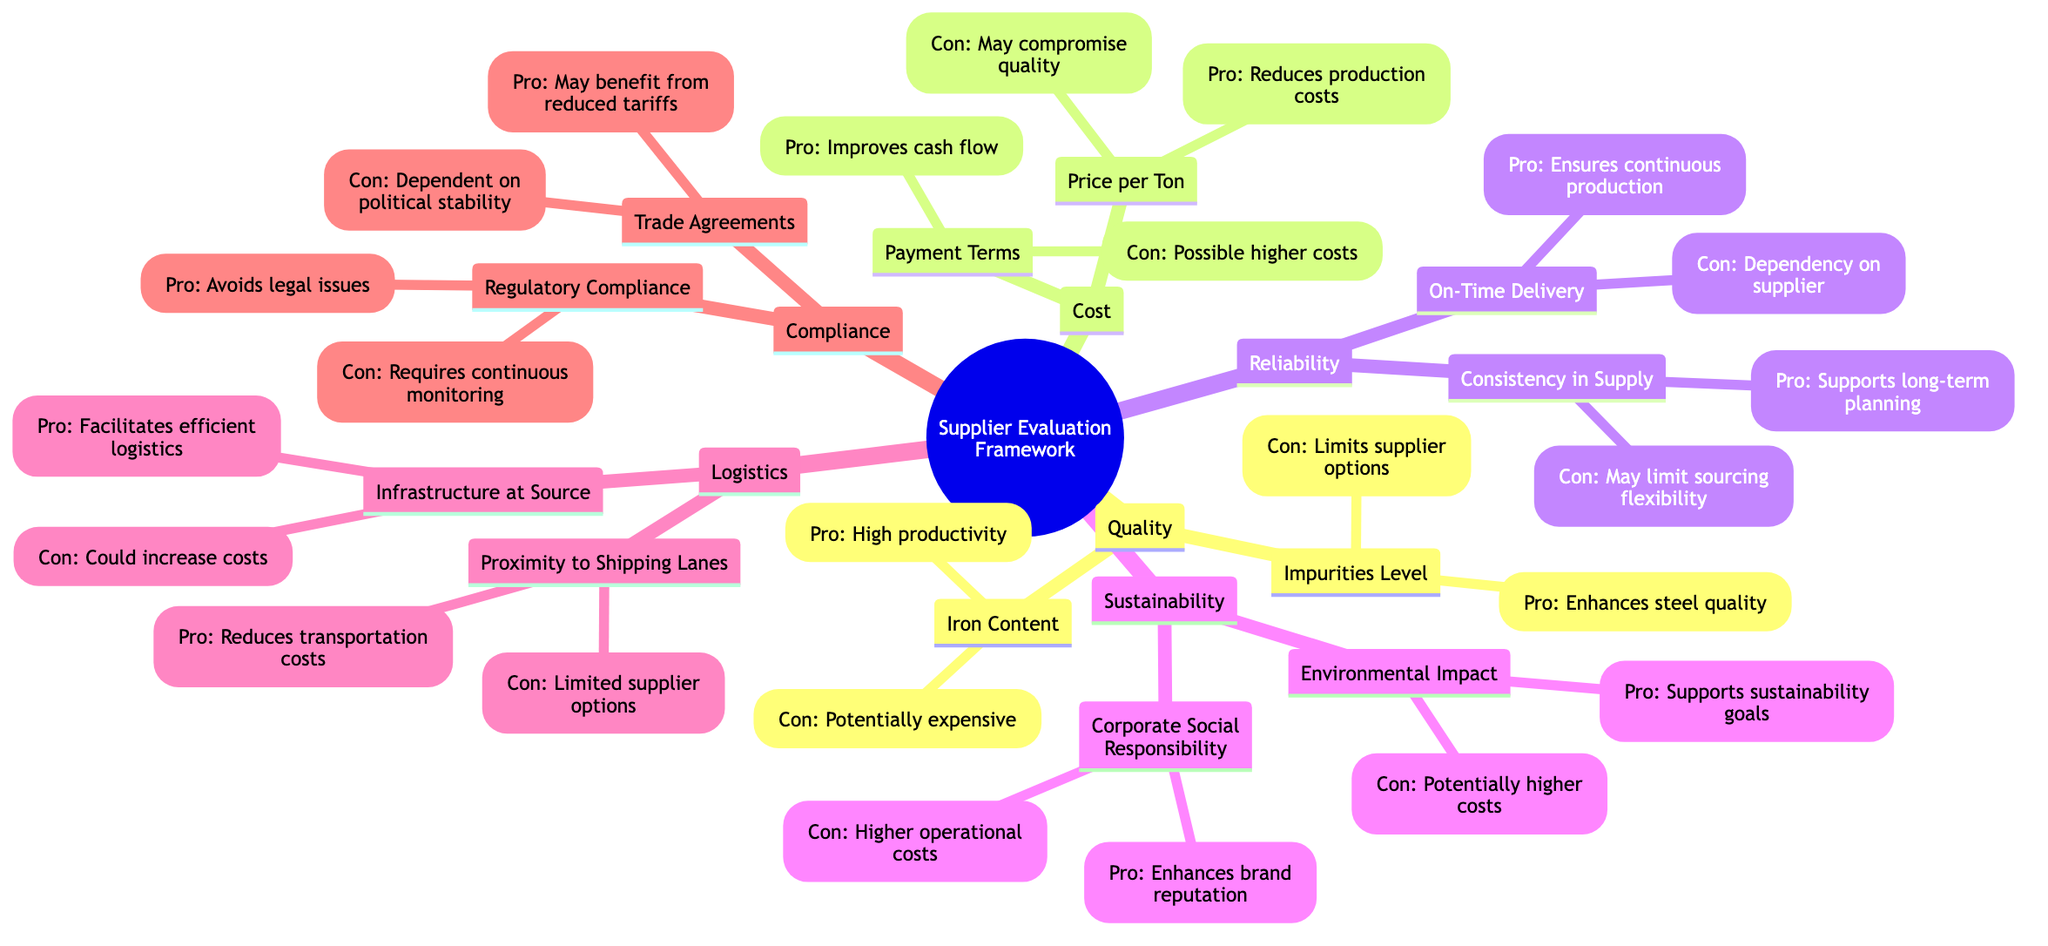What is one pro of high iron content? The pro listed for high iron content is that it increases productivity and reduces waste in steel production.
Answer: High productivity What do lower impurities enhance? According to the diagram, lower impurities enhance steel quality, which is specified as a pro under the Impurities Level category.
Answer: Steel quality How many categories are there in the Supplier Evaluation Framework? The framework contains six main categories: Quality, Cost, Reliability, Sustainability, Logistics, and Compliance.
Answer: Six What is a con of flexible payment terms? The con mentioned for flexible payment terms is that it could lead to possibly higher costs or less favorable terms in other areas.
Answer: Possibly higher costs What is the pro of proximity to shipping lanes? The pro listed for proximity to shipping lanes is that it reduces transportation costs and delivery times.
Answer: Reduces transportation costs Which category does 'On-Time Delivery' belong to? 'On-Time Delivery' is categorized under Reliability in the Supplier Evaluation Framework.
Answer: Reliability What is the relationship between sustainability goals and environmental impact? The diagram states that supporting corporate sustainability goals is a pro of the environmental impact, indicating a direct positive relationship between the two.
Answer: Positive relationship What could strict impurity controls limit? The con of having strict impurity controls under Impurities Level notes that it might limit supplier options.
Answer: Supplier options What enhanced aspect does corporate social responsibility provide? The pro associated with corporate social responsibility indicates that it enhances brand reputation.
Answer: Brand reputation 